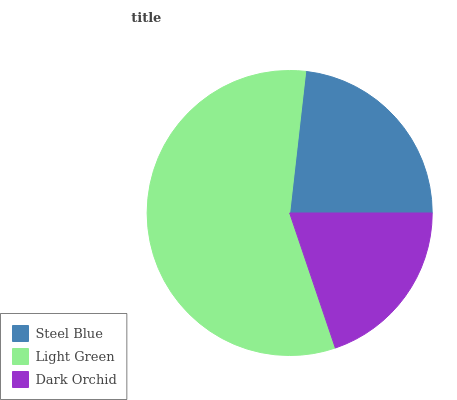Is Dark Orchid the minimum?
Answer yes or no. Yes. Is Light Green the maximum?
Answer yes or no. Yes. Is Light Green the minimum?
Answer yes or no. No. Is Dark Orchid the maximum?
Answer yes or no. No. Is Light Green greater than Dark Orchid?
Answer yes or no. Yes. Is Dark Orchid less than Light Green?
Answer yes or no. Yes. Is Dark Orchid greater than Light Green?
Answer yes or no. No. Is Light Green less than Dark Orchid?
Answer yes or no. No. Is Steel Blue the high median?
Answer yes or no. Yes. Is Steel Blue the low median?
Answer yes or no. Yes. Is Dark Orchid the high median?
Answer yes or no. No. Is Dark Orchid the low median?
Answer yes or no. No. 